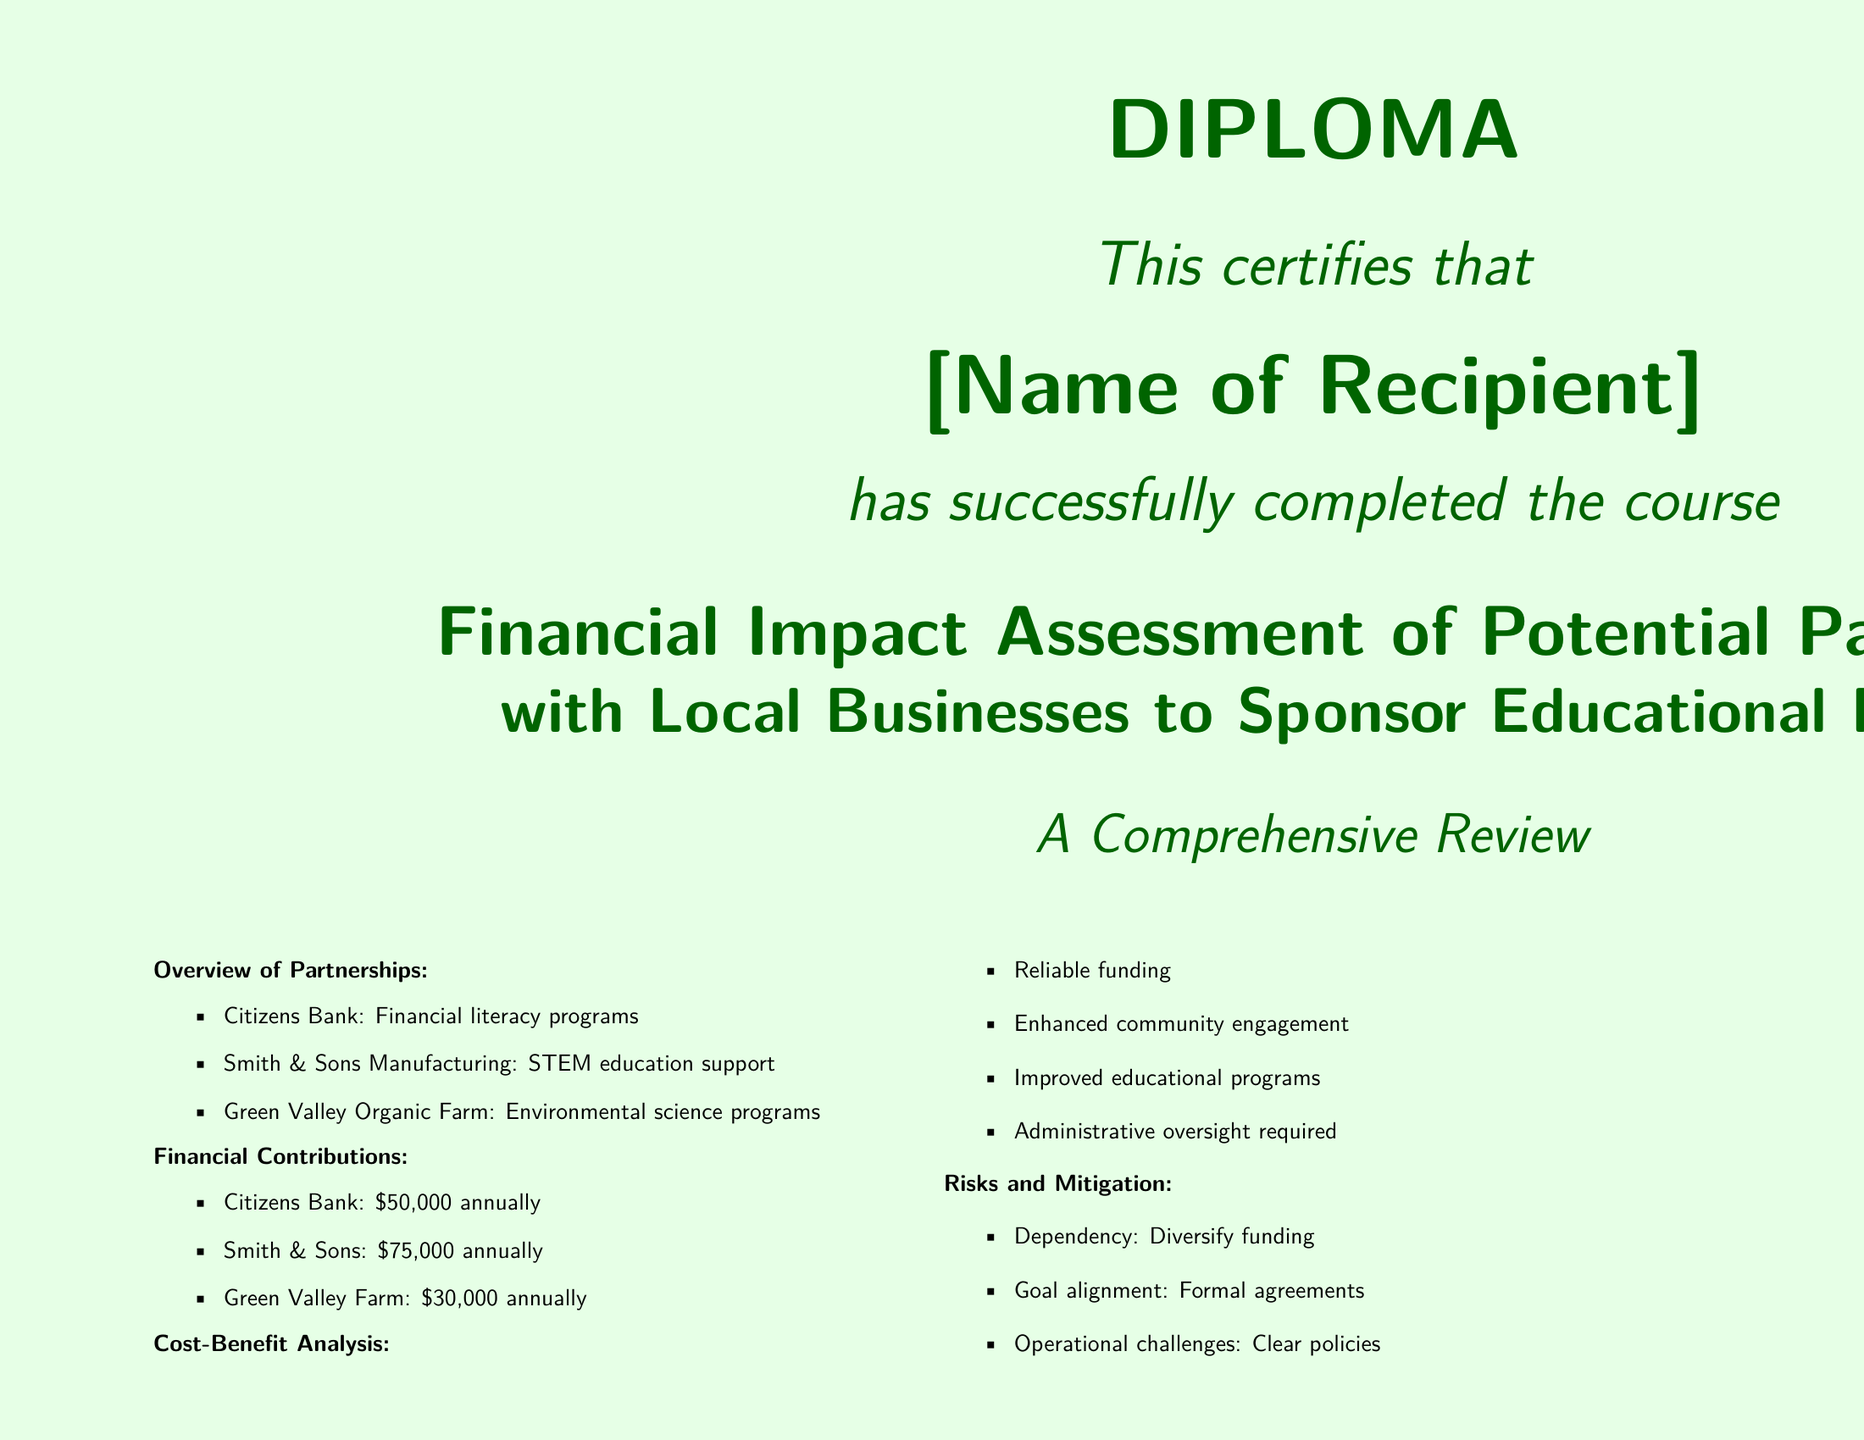what is the title of the diploma? The title is stated prominently in the document, indicating the focus of the course.
Answer: Financial Impact Assessment of Potential Partnerships with Local Businesses to Sponsor Educational Programs who is the recipient of the diploma? The recipient's name is meant to be filled in; it is a placeholder in the document.
Answer: [Name of Recipient] how much does Citizens Bank contribute annually? The contributions of each local business are listed in the financial contributions section of the document.
Answer: $50,000 which business supports STEM education? The document lists the specific partnerships and the areas they support under the overview section.
Answer: Smith & Sons Manufacturing what is one risk mentioned in the document? The document identifies various risks associated with partnerships and lists them under the risks and mitigation section.
Answer: Dependency what is one benefit of the partnerships outlined in the document? The document provides several advantages of establishing partnerships with local businesses as part of the cost-benefit analysis.
Answer: Reliable funding how many businesses are listed as partners in the overview? The overview section explicitly states the number of partnerships explored in the course.
Answer: 3 what does the diploma recognize regarding the recipient's expertise? The closing statement in the document summarizes what the diploma signifies about the recipient's skills and knowledge area.
Answer: Analyzing and leveraging creative funding solutions 